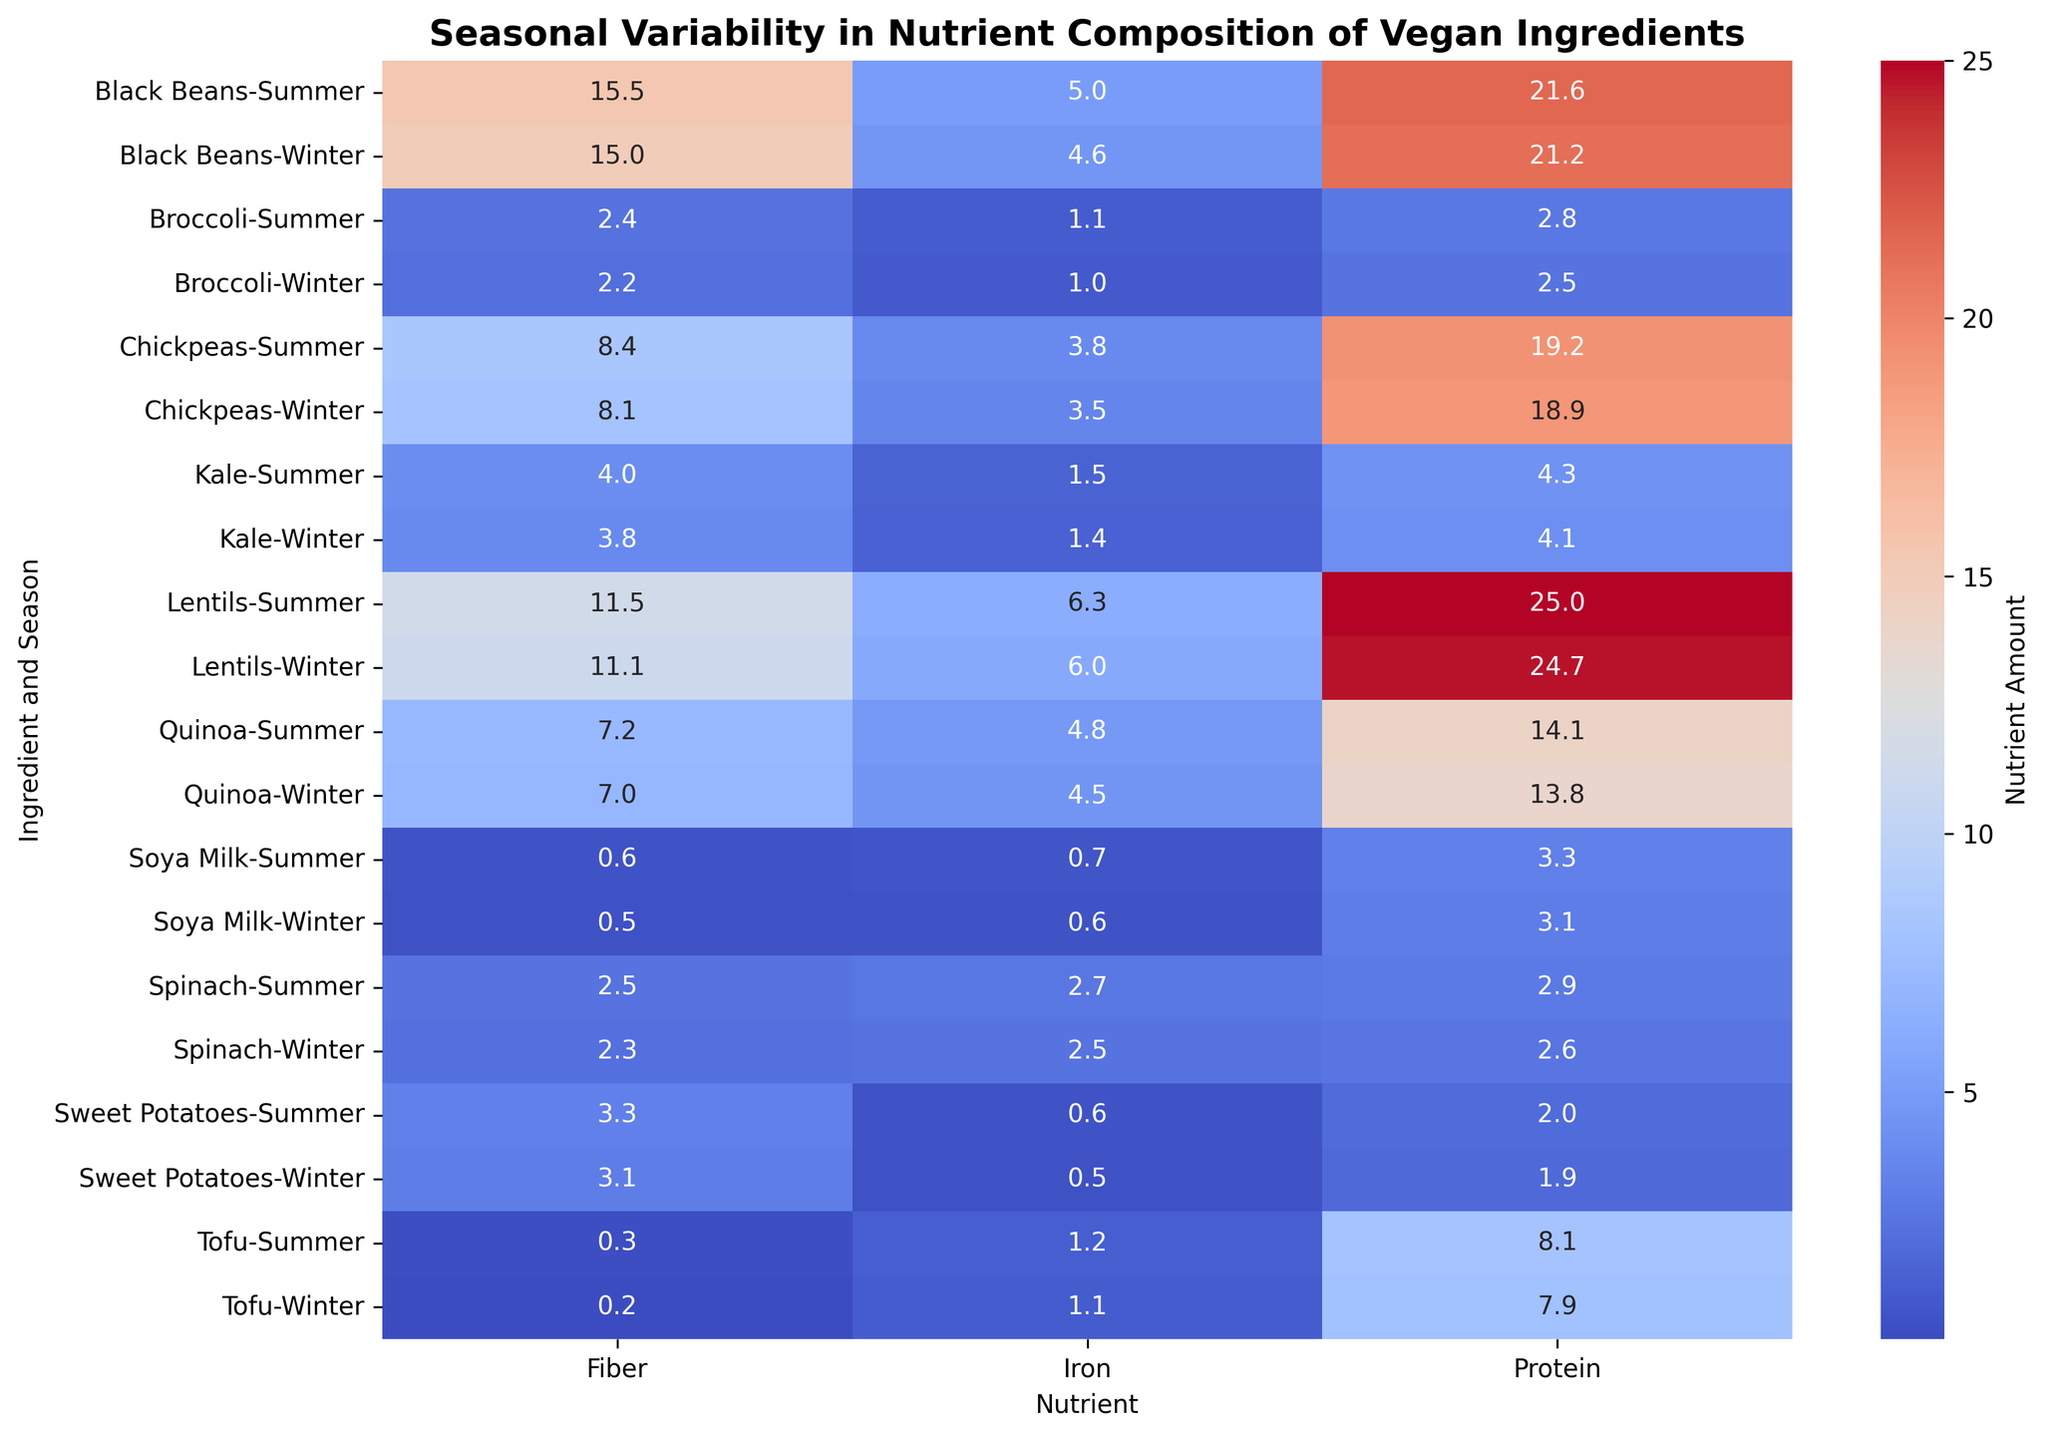What is the difference in protein content of Quinoa between summer and winter? Look at the value for Protein under Quinoa for both Summer and Winter. Subtract the Winter value from the Summer value: 14.1 - 13.8 = 0.3
Answer: 0.3 Which ingredient has the highest amount of fiber in summer? Among the summer values in the Fiber column, identify the maximum value and the corresponding ingredient. The maximum value is 15.5 for Black Beans
Answer: Black Beans Is the iron content in Spinach greater in summer or winter? Compare the values of Iron for Spinach in Summer and Winter. The values are 2.7 (Summer) and 2.5 (Winter). 2.7 is greater than 2.5
Answer: Summer By how much does the fiber content of Kale differ between summer and winter? Look at the Fiber column for Kale in both Summer and Winter. Subtract the Winter value from the Summer value: 4.0 - 3.8 = 0.2
Answer: 0.2 What is the sum of protein content for Soya Milk in both seasons? Add the Protein values for Soya Milk in Summer and Winter: 3.3 + 3.1 = 6.4
Answer: 6.4 Which ingredient shows the smallest seasonal variation in iron content? Calculate the difference between Summer and Winter Iron contents for each ingredient and identify the smallest difference. Tofu has the smallest variation, with a difference of 0.1 (1.2 - 1.1)
Answer: Tofu How does the fiber content of Lentils in summer compare to winter? Compare the Fiber values for Lentils in Summer and Winter. The values are 11.5 (Summer) and 11.1 (Winter). 11.5 is greater than 11.1
Answer: Higher in Summer What is the average amount of iron in Sweet Potatoes across both seasons? Calculate the average of Iron values for Sweet Potatoes in Summer and Winter: (0.6 + 0.5)/2 = 0.55
Answer: 0.55 